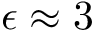Convert formula to latex. <formula><loc_0><loc_0><loc_500><loc_500>\epsilon \approx 3</formula> 